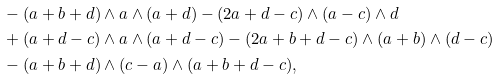Convert formula to latex. <formula><loc_0><loc_0><loc_500><loc_500>& - ( a + b + d ) \wedge a \wedge ( a + d ) - ( 2 a + d - c ) \wedge ( a - c ) \wedge d \\ & + ( a + d - c ) \wedge a \wedge ( a + d - c ) - ( 2 a + b + d - c ) \wedge ( a + b ) \wedge ( d - c ) \\ & - ( a + b + d ) \wedge ( c - a ) \wedge ( a + b + d - c ) ,</formula> 